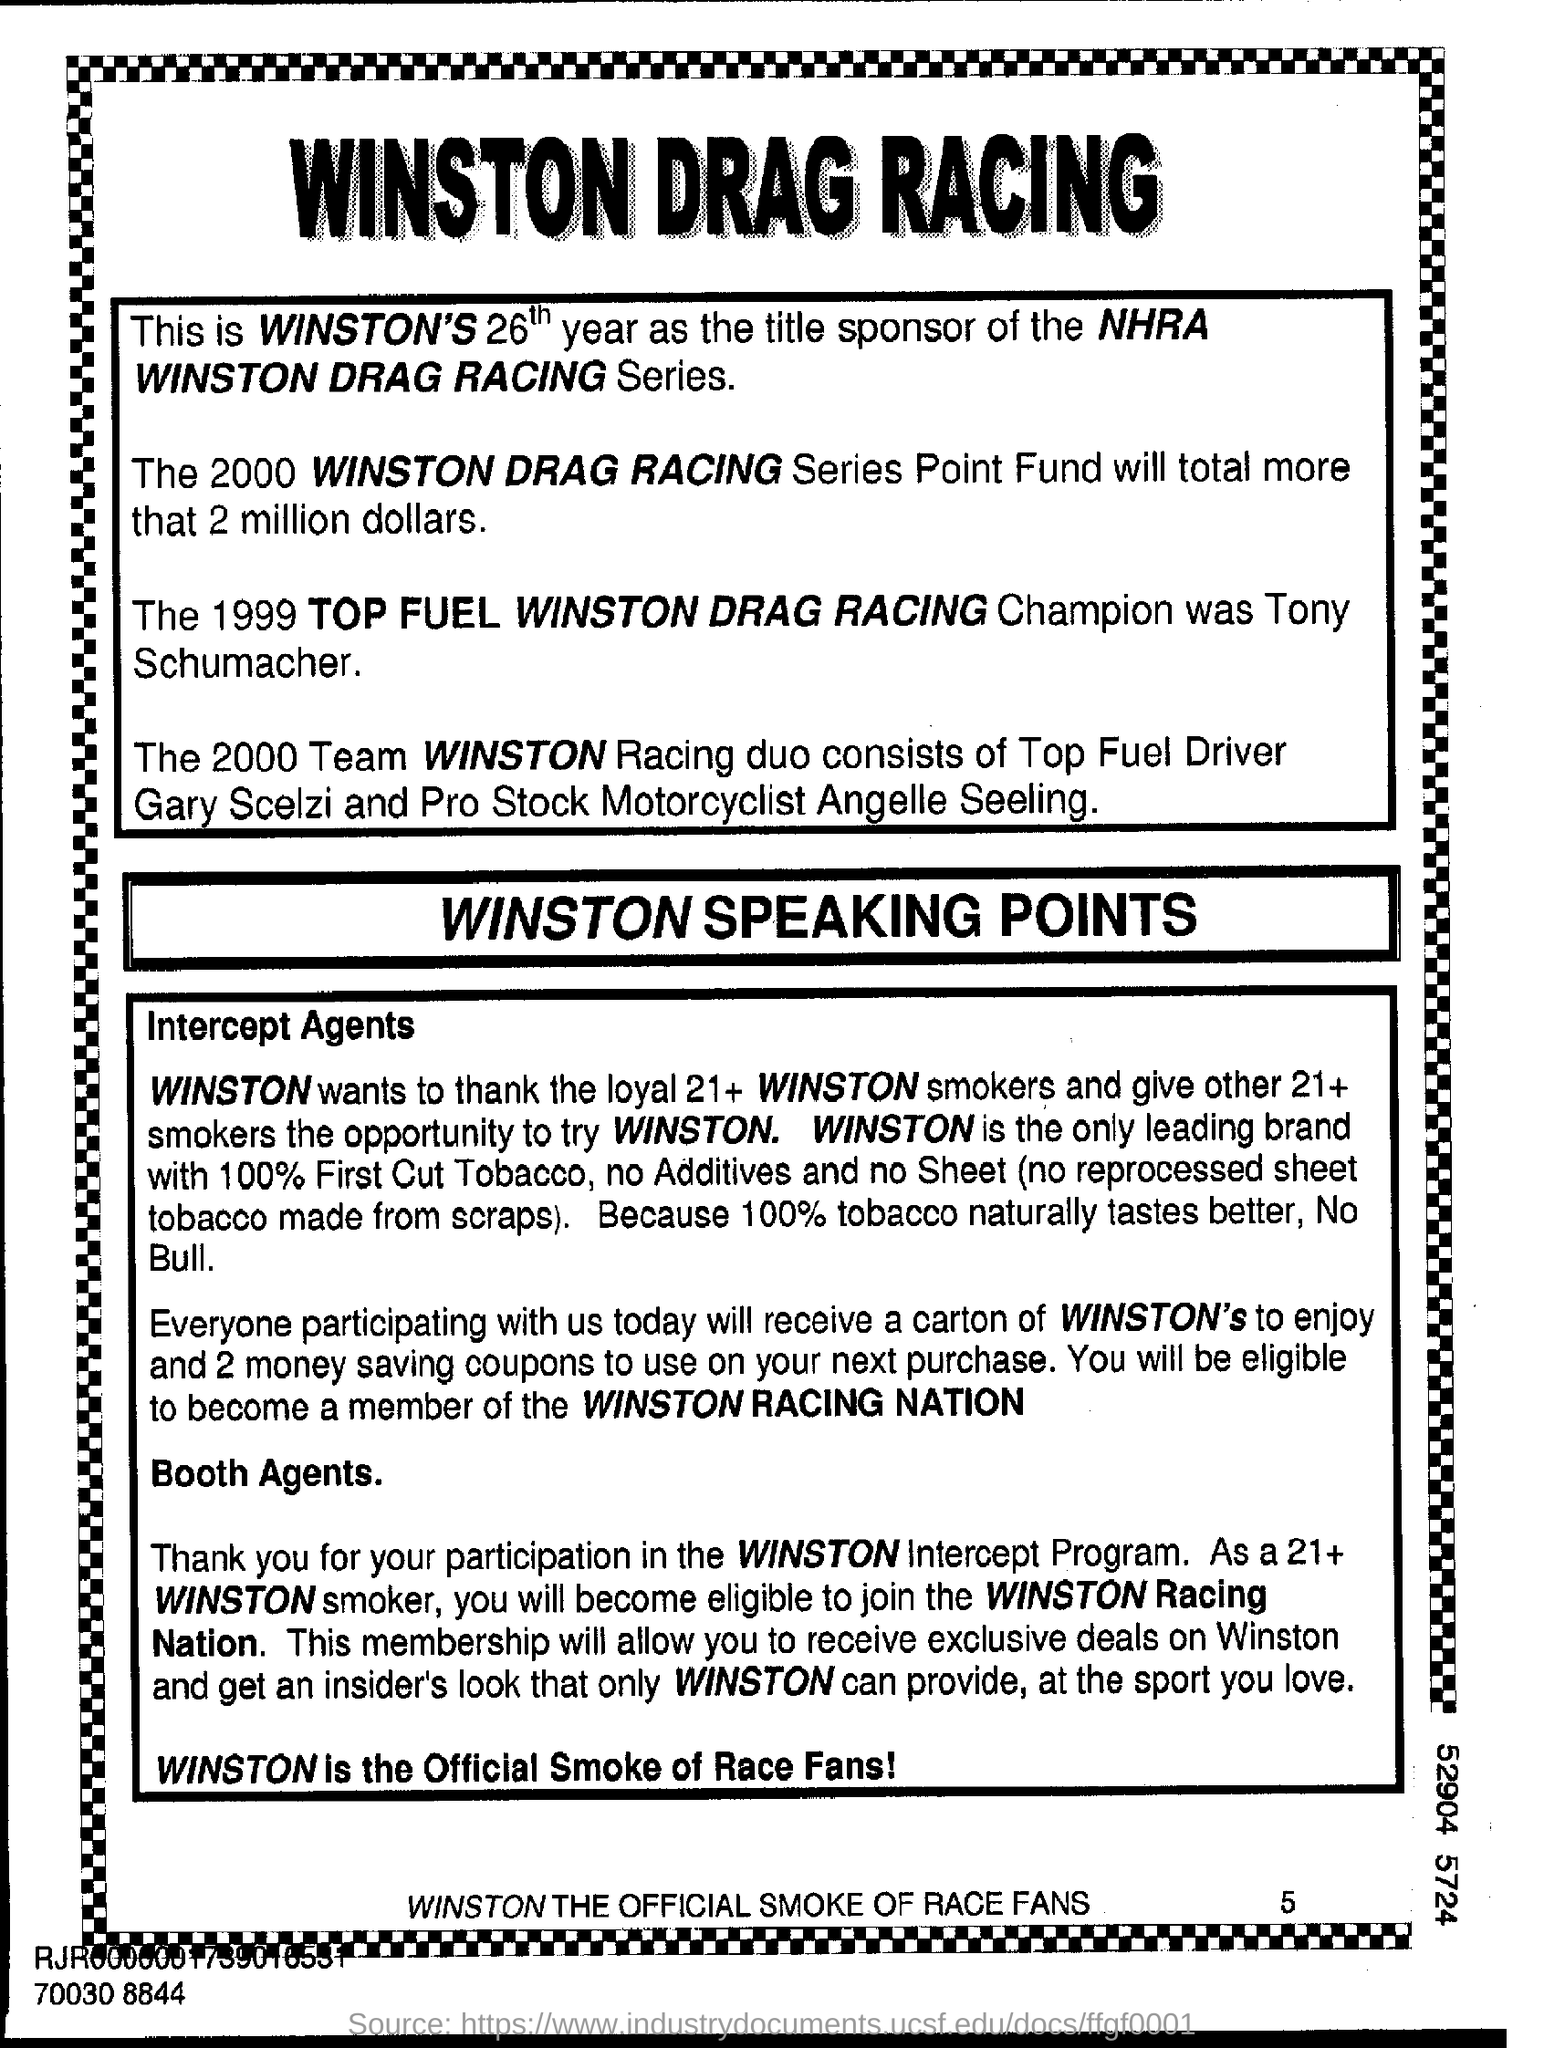Who is the title sponsor of the NHRA Winston Drag Racing Series?
Your answer should be very brief. Winston's. Who is the 1999 Top Fuel Winston Drag Racing Champion?
Ensure brevity in your answer.  Tony Schumacher. 